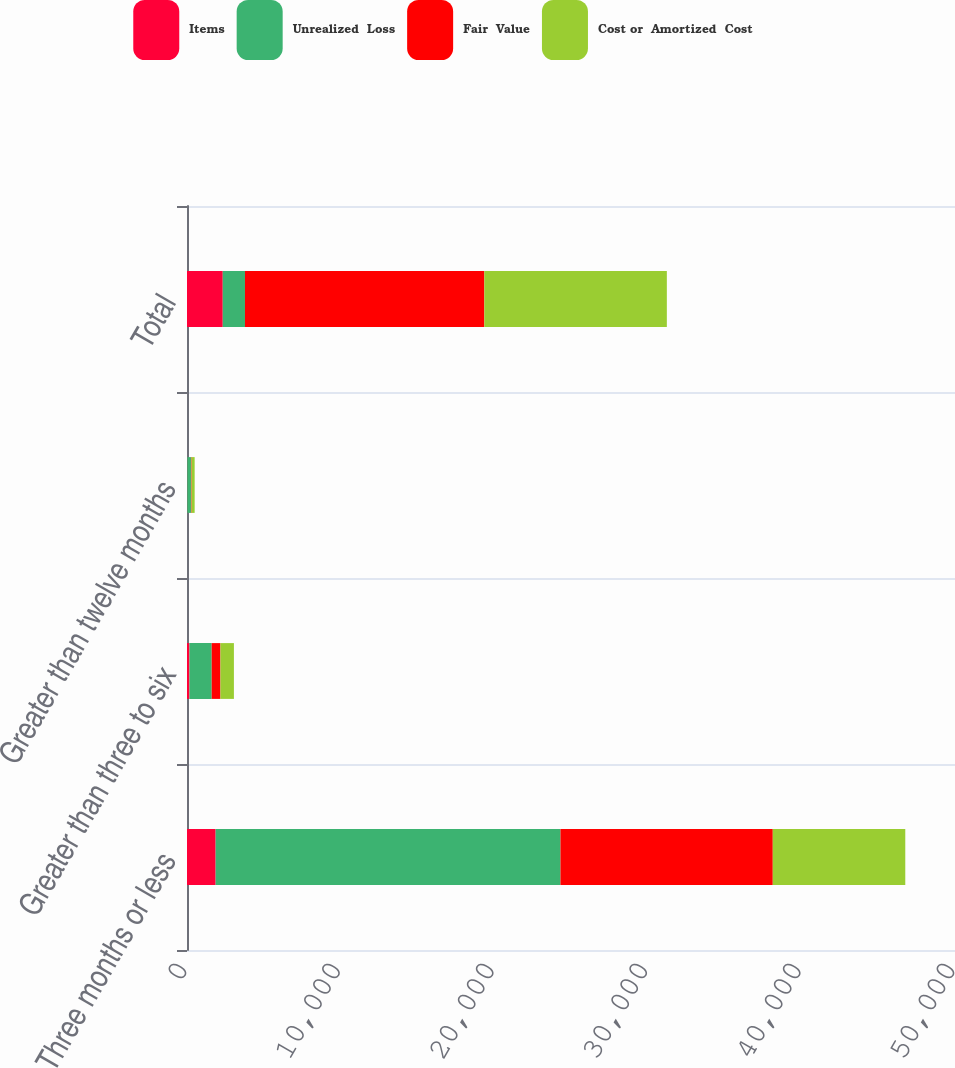Convert chart. <chart><loc_0><loc_0><loc_500><loc_500><stacked_bar_chart><ecel><fcel>Three months or less<fcel>Greater than three to six<fcel>Greater than twelve months<fcel>Total<nl><fcel>Items<fcel>1865<fcel>160<fcel>18<fcel>2328<nl><fcel>Unrealized  Loss<fcel>22449<fcel>1447<fcel>240<fcel>1447<nl><fcel>Fair  Value<fcel>13823<fcel>570<fcel>38<fcel>15582<nl><fcel>Cost or  Amortized  Cost<fcel>8626<fcel>877<fcel>202<fcel>11883<nl></chart> 